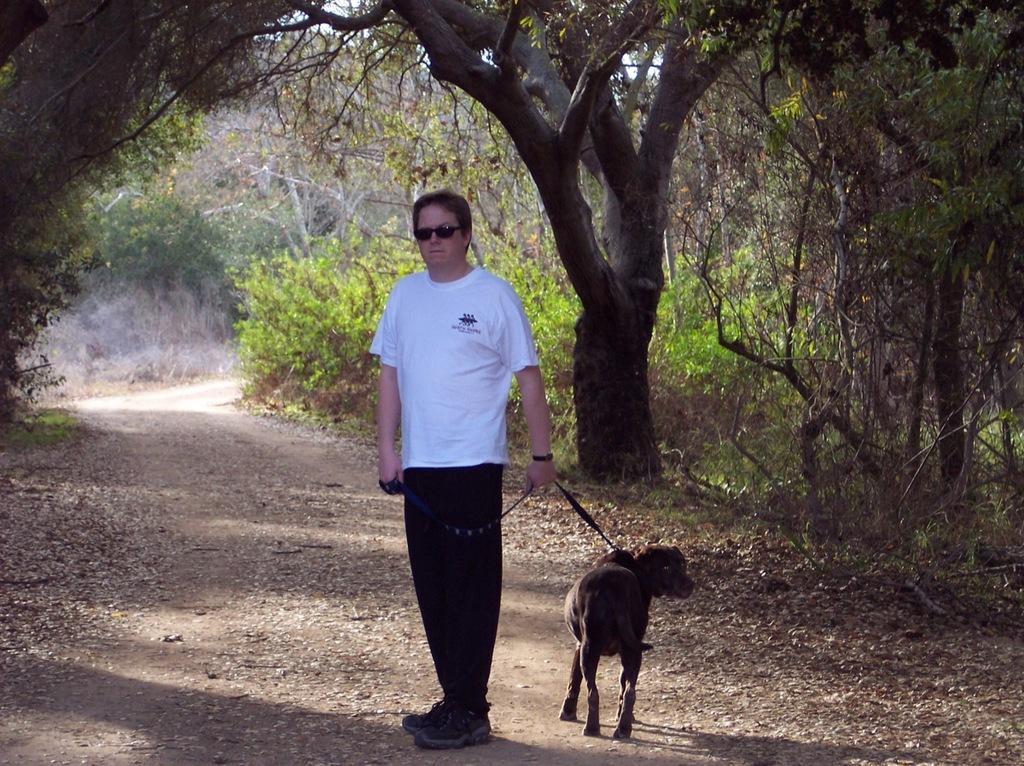Describe this image in one or two sentences. A man wearing a white and black dress also wearing a goggles and watch is holding a dog with a belt. He is standing on a pathway. On the sides there are trees. 